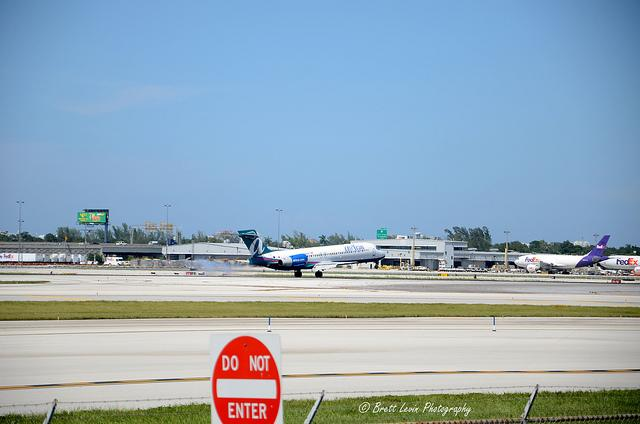What does the sign in front of the runways near the camera say? Please explain your reasoning. enter. The sign is clearly visible and known to be a sign based on design and  shape. the text on the sign is clearly readable. 